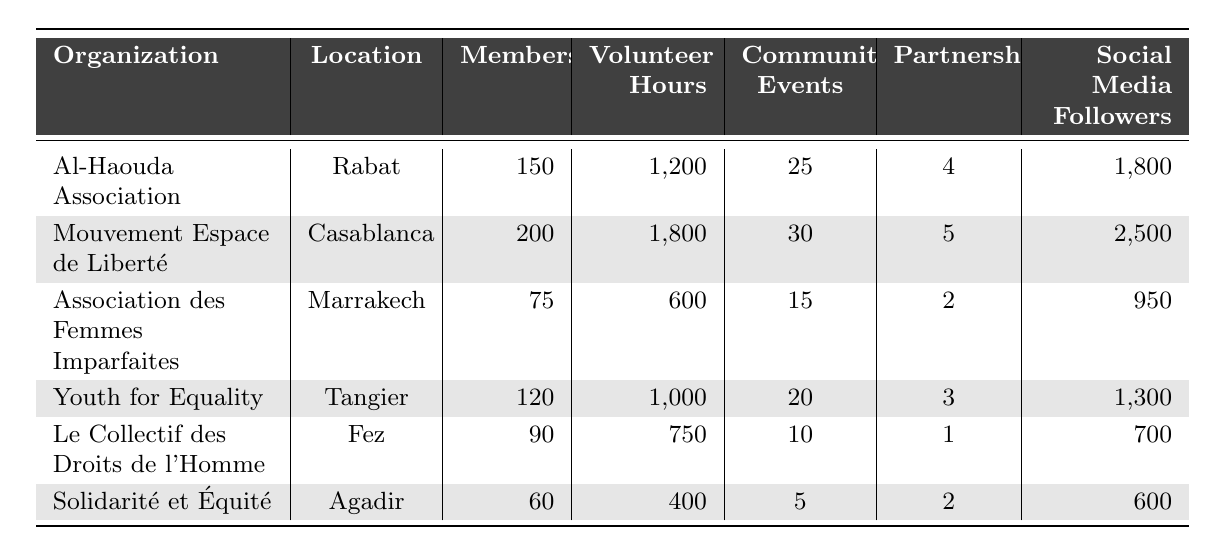What organization has the highest number of members? Looking at the "Members" column, "Mouvement Espace de Liberté" has the highest number of members with 200.
Answer: 200 What is the total number of volunteer hours contributed by all organizations? Adding the volunteer hours from each organization: 1200 + 1800 + 600 + 1000 + 750 + 400 = 4750.
Answer: 4750 Which organization has the most community events? In the "Community Events" column, "Mouvement Espace de Liberté" has the highest with 30 events.
Answer: 30 Is "Solidarité et Équité" the organization with the fewest social media followers? Comparing the "Social Media Followers" of all organizations, "Solidarité et Équité" has 600, which is indeed the lowest.
Answer: Yes What is the average number of partnerships among the organizations? Total partnerships: 4 + 5 + 2 + 3 + 1 + 2 = 17; Number of organizations = 6. Average = 17/6 = 2.83.
Answer: 2.83 Which organization has more volunteer hours: "Youth for Equality" or "Le Collectif des Droits de l'Homme"? "Youth for Equality" has 1000 volunteer hours while "Le Collectif des Droits de l'Homme" has 750, so "Youth for Equality" has more.
Answer: Youth for Equality What is the difference in the number of community events between "Al-Haouda Association" and "Association des Femmes Imparfaites"? "Al-Haouda Association" has 25 community events and "Association des Femmes Imparfaites" has 15. The difference is 25 - 15 = 10.
Answer: 10 What percentage of members does "Mouvement Espace de Liberté" represent among all members of the organizations? Total members = 150 + 200 + 75 + 120 + 90 + 60 = 695; "Mouvement Espace de Liberté" has 200 members. Percentage = (200 / 695) * 100 = 28.8%.
Answer: 28.8% Which location has the least number of members? Reviewing the "Members" column, "Solidarité et Équité" in Agadir has the least with 60 members.
Answer: 60 How many social media followers do the organizations collectively have? Adding the social media followers: 1800 + 2500 + 950 + 1300 + 700 + 600 = 6850.
Answer: 6850 